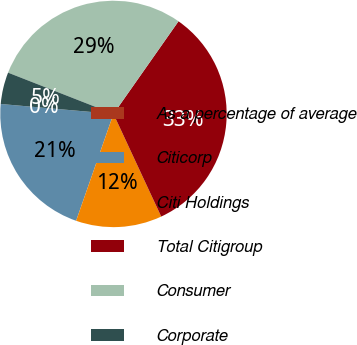Convert chart. <chart><loc_0><loc_0><loc_500><loc_500><pie_chart><fcel>As a percentage of average<fcel>Citicorp<fcel>Citi Holdings<fcel>Total Citigroup<fcel>Consumer<fcel>Corporate<nl><fcel>0.0%<fcel>21.05%<fcel>12.28%<fcel>33.33%<fcel>28.8%<fcel>4.54%<nl></chart> 